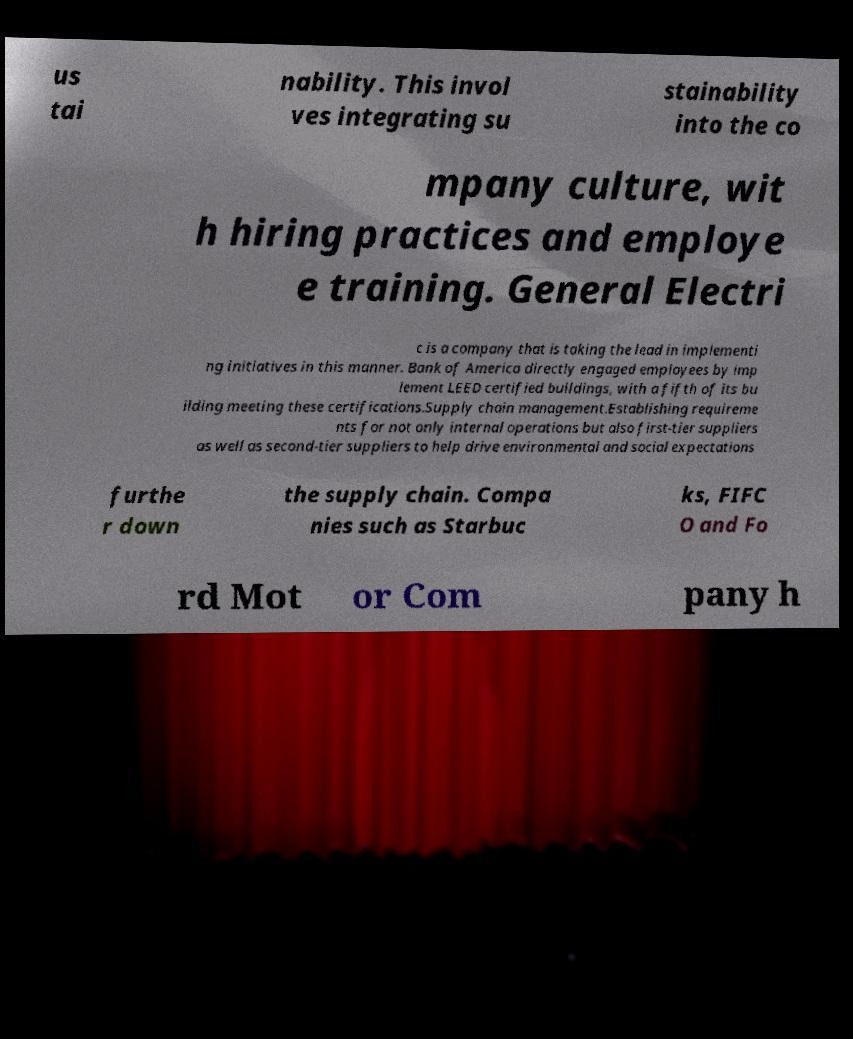Please read and relay the text visible in this image. What does it say? us tai nability. This invol ves integrating su stainability into the co mpany culture, wit h hiring practices and employe e training. General Electri c is a company that is taking the lead in implementi ng initiatives in this manner. Bank of America directly engaged employees by imp lement LEED certified buildings, with a fifth of its bu ilding meeting these certifications.Supply chain management.Establishing requireme nts for not only internal operations but also first-tier suppliers as well as second-tier suppliers to help drive environmental and social expectations furthe r down the supply chain. Compa nies such as Starbuc ks, FIFC O and Fo rd Mot or Com pany h 